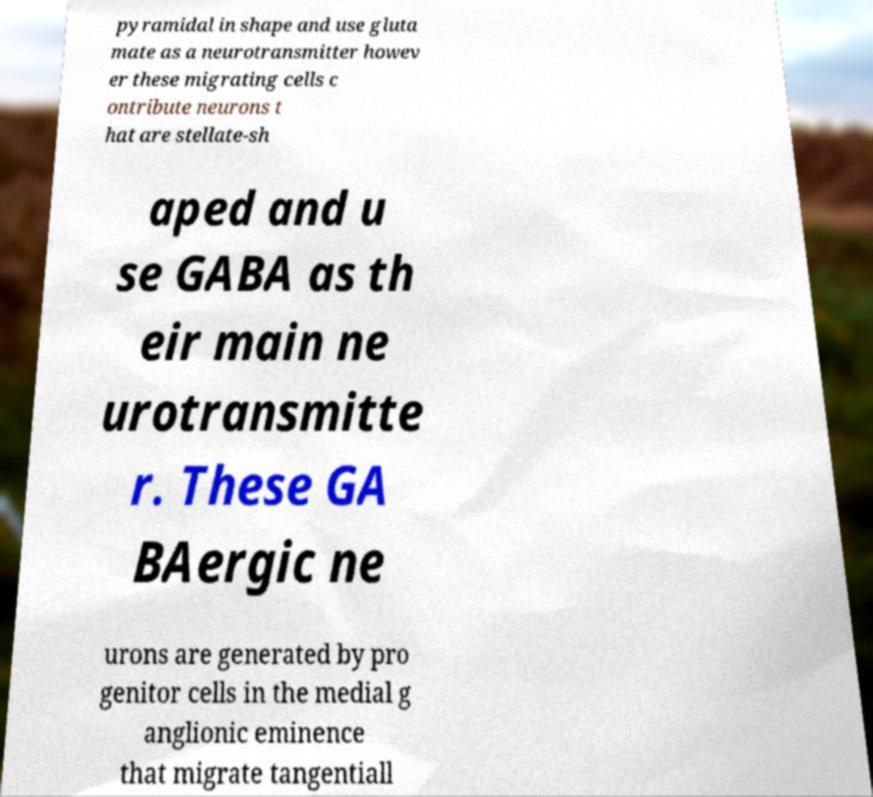For documentation purposes, I need the text within this image transcribed. Could you provide that? pyramidal in shape and use gluta mate as a neurotransmitter howev er these migrating cells c ontribute neurons t hat are stellate-sh aped and u se GABA as th eir main ne urotransmitte r. These GA BAergic ne urons are generated by pro genitor cells in the medial g anglionic eminence that migrate tangentiall 